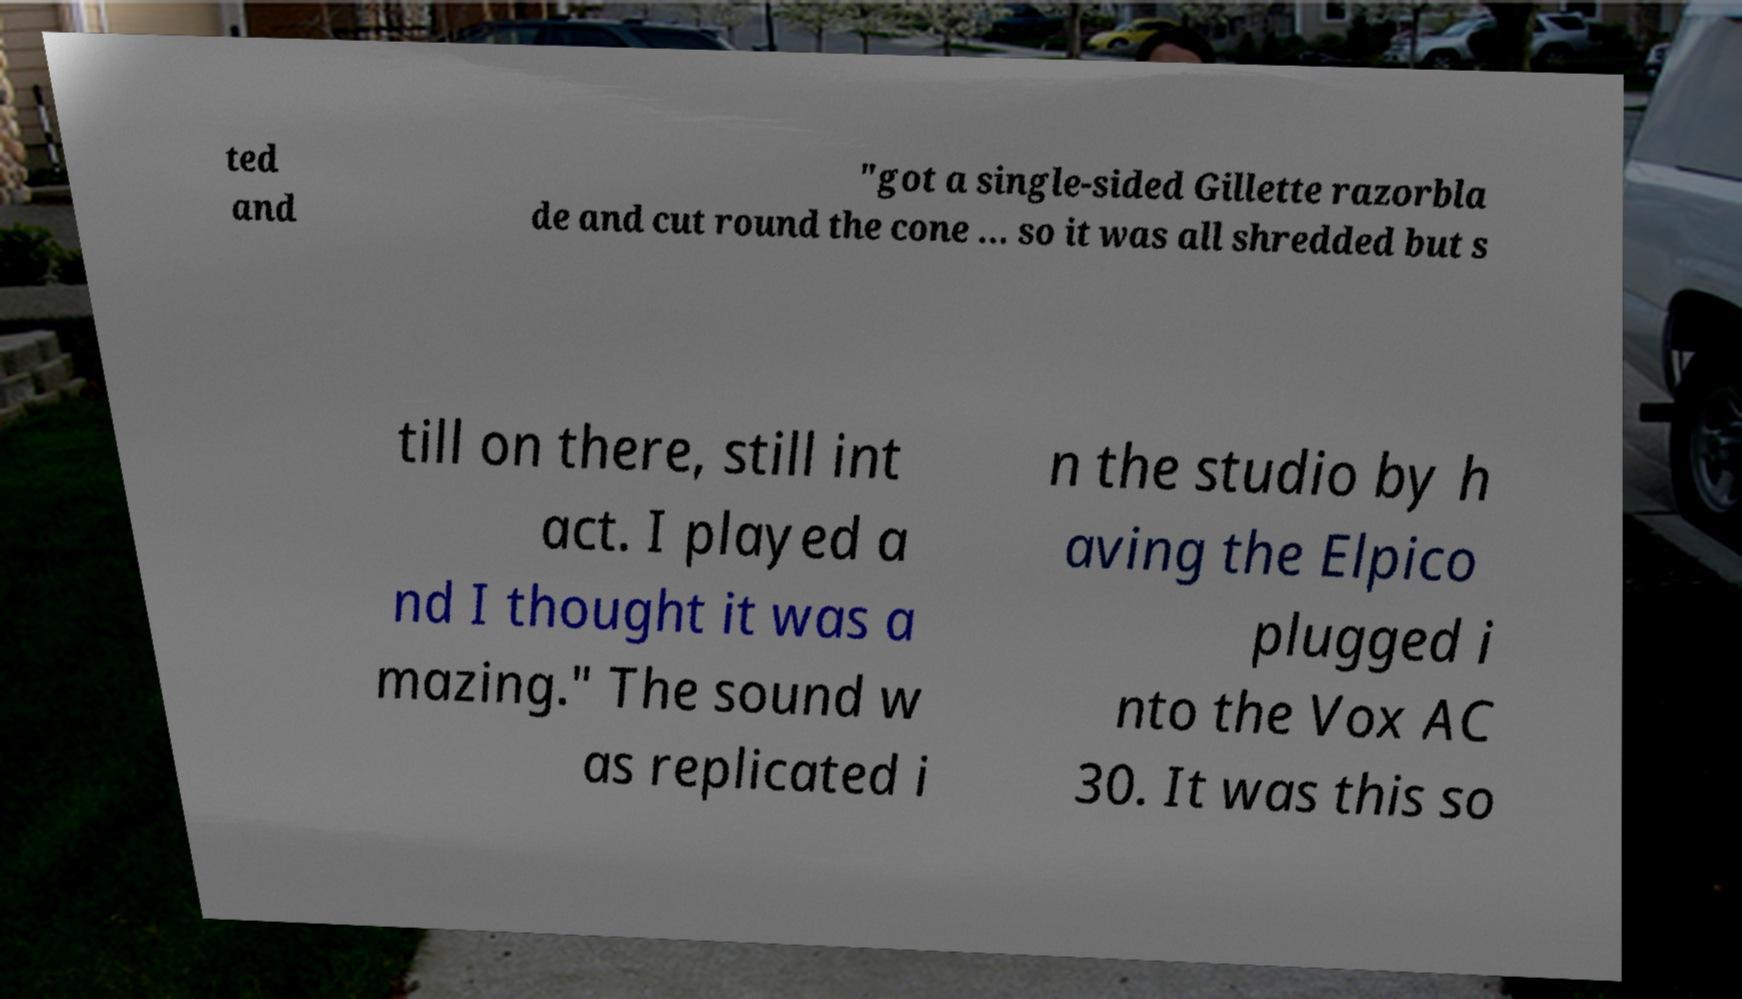Please read and relay the text visible in this image. What does it say? ted and "got a single-sided Gillette razorbla de and cut round the cone ... so it was all shredded but s till on there, still int act. I played a nd I thought it was a mazing." The sound w as replicated i n the studio by h aving the Elpico plugged i nto the Vox AC 30. It was this so 